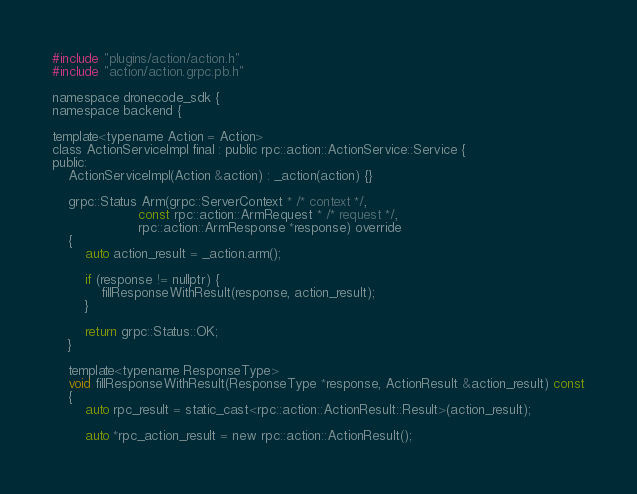Convert code to text. <code><loc_0><loc_0><loc_500><loc_500><_C_>#include "plugins/action/action.h"
#include "action/action.grpc.pb.h"

namespace dronecode_sdk {
namespace backend {

template<typename Action = Action>
class ActionServiceImpl final : public rpc::action::ActionService::Service {
public:
    ActionServiceImpl(Action &action) : _action(action) {}

    grpc::Status Arm(grpc::ServerContext * /* context */,
                     const rpc::action::ArmRequest * /* request */,
                     rpc::action::ArmResponse *response) override
    {
        auto action_result = _action.arm();

        if (response != nullptr) {
            fillResponseWithResult(response, action_result);
        }

        return grpc::Status::OK;
    }

    template<typename ResponseType>
    void fillResponseWithResult(ResponseType *response, ActionResult &action_result) const
    {
        auto rpc_result = static_cast<rpc::action::ActionResult::Result>(action_result);

        auto *rpc_action_result = new rpc::action::ActionResult();</code> 